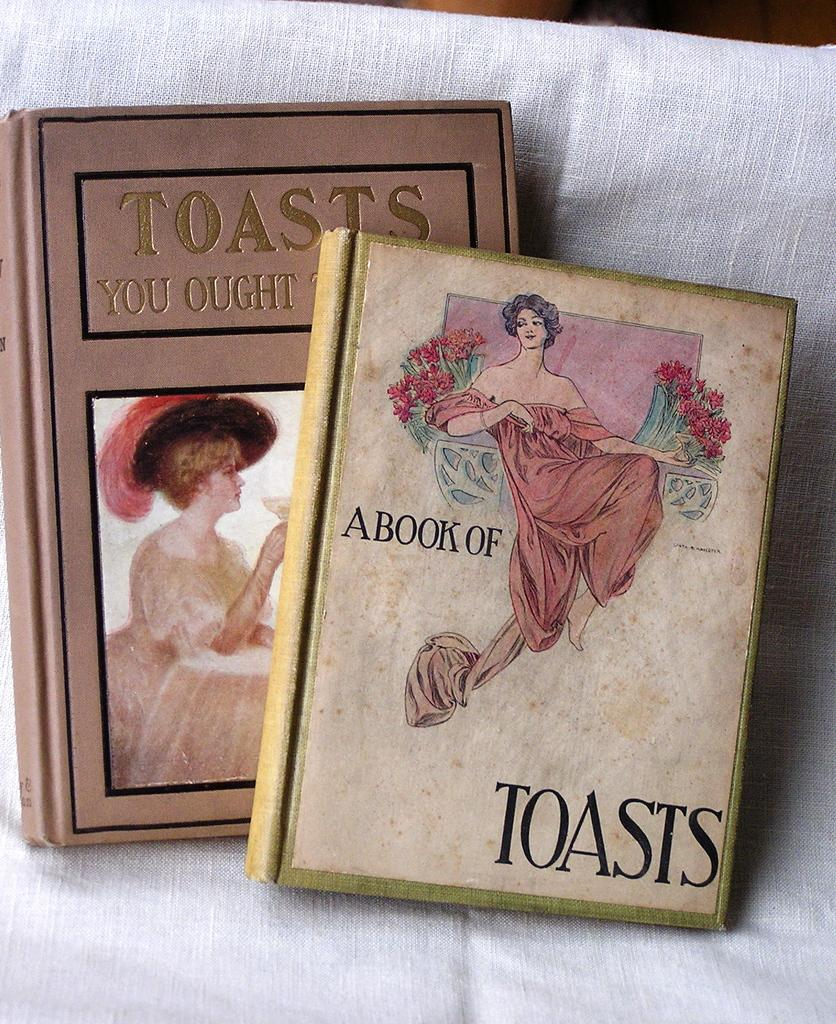What is the main color of the cloth in the image? The main color of the cloth in the image is white. What objects are placed on the white cloth? There are 2 books on the white cloth. What can be seen in the depictions on the image? There are depictions of women in the image. What information is available on the books? Words are written on the books. What type of vessel is used to transport the books in the image? There is no vessel present in the image, and the books are not being transported. 